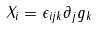<formula> <loc_0><loc_0><loc_500><loc_500>X _ { i } = \epsilon _ { i j k } \partial _ { j } g _ { k }</formula> 